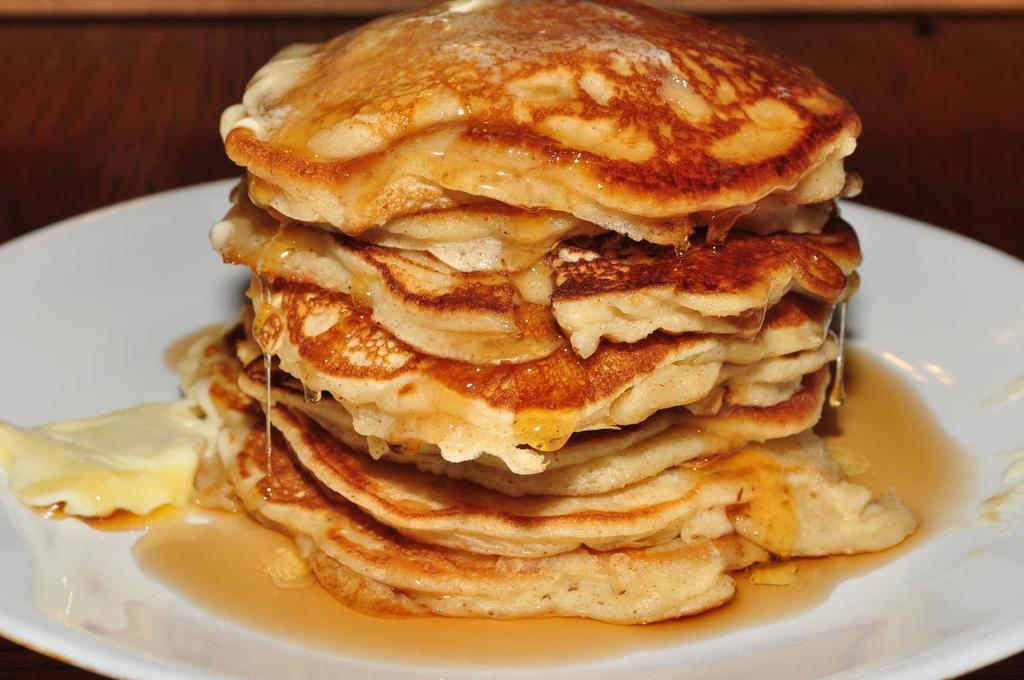What is on the plate that is visible in the image? There is a white plate in the image, and there are pancakes on the plate. What is on top of the pancakes? Honey is present on the pancakes. How would you describe the background of the image? The background of the image is blurred. What is the opinion of the pancakes in the image? There is no indication of an opinion about the pancakes in the image; it simply shows pancakes with honey on them. 